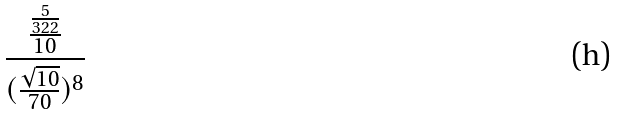Convert formula to latex. <formula><loc_0><loc_0><loc_500><loc_500>\frac { \frac { \frac { 5 } { 3 2 2 } } { 1 0 } } { ( \frac { \sqrt { 1 0 } } { 7 0 } ) ^ { 8 } }</formula> 